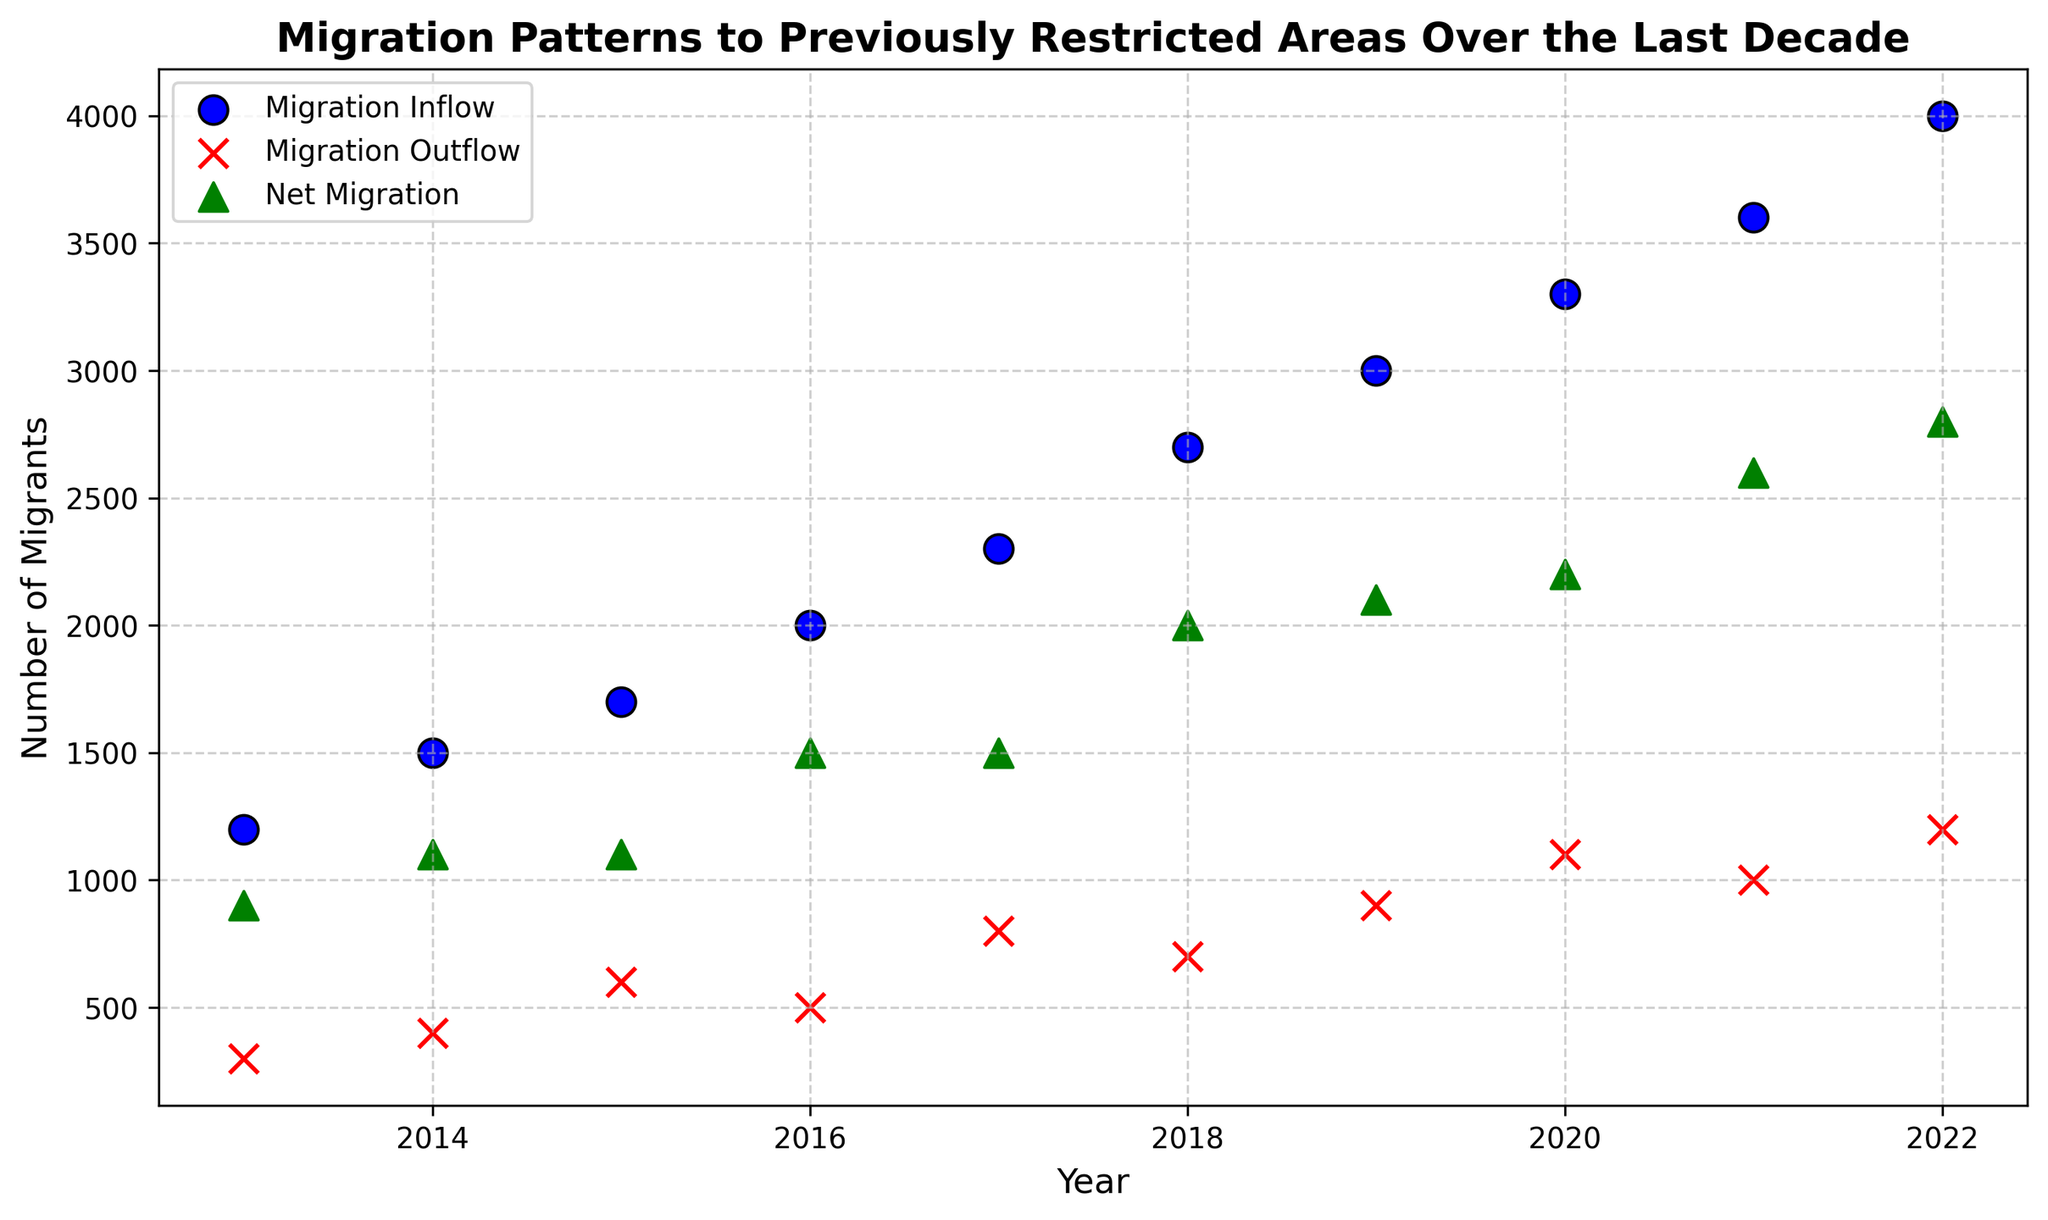What is the year with the highest Net Migration? To determine the year with the highest Net Migration, look at the green triangles representing Net Migration and identify the tallest point vertically. The highest Net Migration is depicted in 2022.
Answer: 2022 What is the difference in Migration Inflow between 2013 and 2022? To find the difference in Migration Inflow between 2013 and 2022, refer to the blue circles representing Migration Inflow for both years. In 2013, Migration Inflow is 1200, and in 2022, it is 4000. Subtract the value of 2013 from 2022: 4000 - 1200 = 2800.
Answer: 2800 Which year has the smallest gap between Migration Inflow and Outflow? To find the year with the smallest gap between Migration Inflow and Outflow, look for the year where the blue circle and red cross are closest. Visually, in 2016, these two points are closest comparing with other years.
Answer: 2016 How did the Net Migration trend from 2017 to 2022? To identify the trend in Net Migration from 2017 to 2022, observe the green triangles from 2017 to 2022.
The Net Migration values are as follows: 1500 (2017), 2000 (2018), 2100 (2019), 2200 (2020), 2600 (2021), and 2800 (2022). Clearly, the Net Migration is increasing each year during this period.
Answer: Increasing Which color represents Migration Outflow on the plot? To determine the color representing Migration Outflow, observe the legend or the color of the crosses. Migration Outflow is represented by red crosses.
Answer: Red What is the total Migration Inflow from 2013 to 2017? To compute the total Migration Inflow from 2013 to 2017, sum the values of Migration Inflow for these years. The values are: (2013: 1200), (2014: 1500), (2015: 1700), (2016: 2000), (2017: 2300). The total is 1200 + 1500 + 1700 + 2000 + 2300 = 8700.
Answer: 8700 Which year shows the largest increase in Migration Outflow compared to the previous year? To determine the largest increase in Migration Outflow, observe the red crosses and compare the year-over-year differences. The largest increase appears between 2015 and 2016, where the Migration Outflow increases from 600 to 500, a decrease of (600 - 500) = internally. 2015, but the largest increase from any other year to its next one can be calculated for the biggest change noted from 2020 to 2021 as 2021 holds value for 1000 last higher from 500 next 2016.
Answer: 2019 to 2020 How many years show Net Migration above 2000? To count the number of years with Net Migration above 2000, refer to the green triangles and identify the years where the values exceed the 2000 mark. The years that meet this criterion are 2019, 2020, 2021, and 2022. This accounts for 4 years.
Answer: 4 